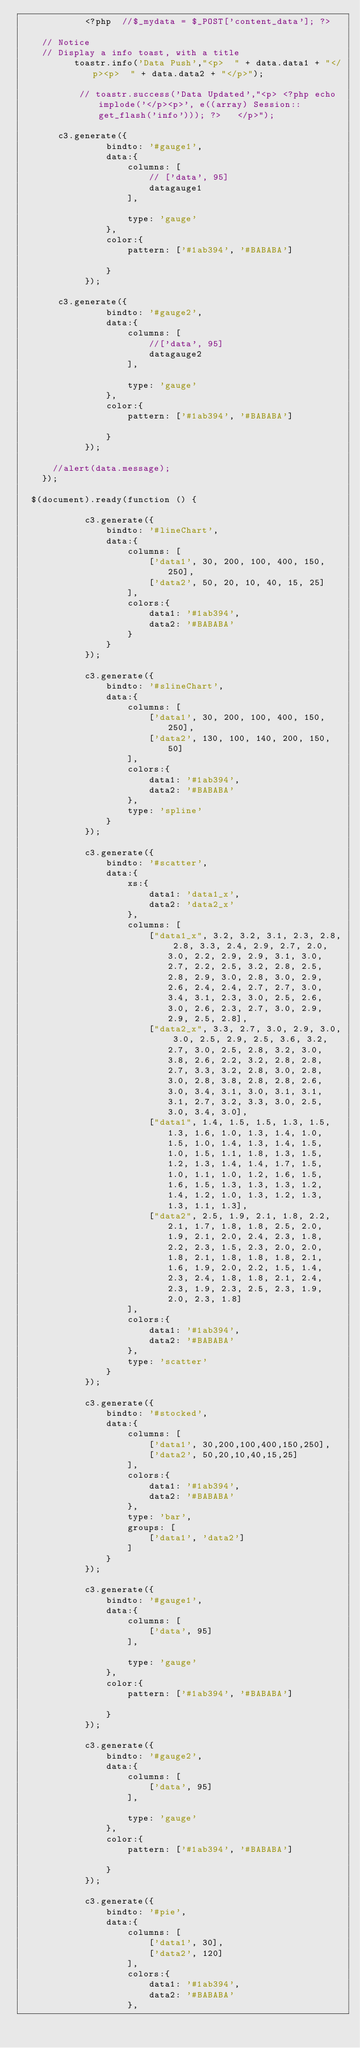Convert code to text. <code><loc_0><loc_0><loc_500><loc_500><_PHP_>           	<?php  //$_mydata = $_POST['content_data']; ?>

		// Notice 
		// Display a info toast, with a title
          toastr.info('Data Push',"<p>  " + data.data1 + "</p><p>  " + data.data2 + "</p>");

           // toastr.success('Data Updated',"<p> <?php echo implode('</p><p>', e((array) Session::get_flash('info'))); ?>  	</p>"); 

       c3.generate({
                bindto: '#gauge1',
                data:{
                    columns: [
                        // ['data', 95]
                        datagauge1
                    ],

                    type: 'gauge'
                },
                color:{
                    pattern: ['#1ab394', '#BABABA']

                }
            });

       c3.generate({
                bindto: '#gauge2',
                data:{
                    columns: [
                        //['data', 95]
                        datagauge2
                    ],

                    type: 'gauge'
                },
                color:{
                    pattern: ['#1ab394', '#BABABA']

                }
            });

      //alert(data.message);
    });

	$(document).ready(function () {

            c3.generate({
                bindto: '#lineChart',
                data:{
                    columns: [
                        ['data1', 30, 200, 100, 400, 150, 250],
                        ['data2', 50, 20, 10, 40, 15, 25]
                    ],
                    colors:{
                        data1: '#1ab394',
                        data2: '#BABABA'
                    }
                }
            });

            c3.generate({
                bindto: '#slineChart',
                data:{
                    columns: [
                        ['data1', 30, 200, 100, 400, 150, 250],
                        ['data2', 130, 100, 140, 200, 150, 50]
                    ],
                    colors:{
                        data1: '#1ab394',
                        data2: '#BABABA'
                    },
                    type: 'spline'
                }
            });

            c3.generate({
                bindto: '#scatter',
                data:{
                    xs:{
                        data1: 'data1_x',
                        data2: 'data2_x'
                    },
                    columns: [
                        ["data1_x", 3.2, 3.2, 3.1, 2.3, 2.8, 2.8, 3.3, 2.4, 2.9, 2.7, 2.0, 3.0, 2.2, 2.9, 2.9, 3.1, 3.0, 2.7, 2.2, 2.5, 3.2, 2.8, 2.5, 2.8, 2.9, 3.0, 2.8, 3.0, 2.9, 2.6, 2.4, 2.4, 2.7, 2.7, 3.0, 3.4, 3.1, 2.3, 3.0, 2.5, 2.6, 3.0, 2.6, 2.3, 2.7, 3.0, 2.9, 2.9, 2.5, 2.8],
                        ["data2_x", 3.3, 2.7, 3.0, 2.9, 3.0, 3.0, 2.5, 2.9, 2.5, 3.6, 3.2, 2.7, 3.0, 2.5, 2.8, 3.2, 3.0, 3.8, 2.6, 2.2, 3.2, 2.8, 2.8, 2.7, 3.3, 3.2, 2.8, 3.0, 2.8, 3.0, 2.8, 3.8, 2.8, 2.8, 2.6, 3.0, 3.4, 3.1, 3.0, 3.1, 3.1, 3.1, 2.7, 3.2, 3.3, 3.0, 2.5, 3.0, 3.4, 3.0],
                        ["data1", 1.4, 1.5, 1.5, 1.3, 1.5, 1.3, 1.6, 1.0, 1.3, 1.4, 1.0, 1.5, 1.0, 1.4, 1.3, 1.4, 1.5, 1.0, 1.5, 1.1, 1.8, 1.3, 1.5, 1.2, 1.3, 1.4, 1.4, 1.7, 1.5, 1.0, 1.1, 1.0, 1.2, 1.6, 1.5, 1.6, 1.5, 1.3, 1.3, 1.3, 1.2, 1.4, 1.2, 1.0, 1.3, 1.2, 1.3, 1.3, 1.1, 1.3],
                        ["data2", 2.5, 1.9, 2.1, 1.8, 2.2, 2.1, 1.7, 1.8, 1.8, 2.5, 2.0, 1.9, 2.1, 2.0, 2.4, 2.3, 1.8, 2.2, 2.3, 1.5, 2.3, 2.0, 2.0, 1.8, 2.1, 1.8, 1.8, 1.8, 2.1, 1.6, 1.9, 2.0, 2.2, 1.5, 1.4, 2.3, 2.4, 1.8, 1.8, 2.1, 2.4, 2.3, 1.9, 2.3, 2.5, 2.3, 1.9, 2.0, 2.3, 1.8]
                    ],
                    colors:{
                        data1: '#1ab394',
                        data2: '#BABABA'
                    },
                    type: 'scatter'
                }
            });

            c3.generate({
                bindto: '#stocked',
                data:{
                    columns: [
                        ['data1', 30,200,100,400,150,250],
                        ['data2', 50,20,10,40,15,25]
                    ],
                    colors:{
                        data1: '#1ab394',
                        data2: '#BABABA'
                    },
                    type: 'bar',
                    groups: [
                        ['data1', 'data2']
                    ]
                }
            });

            c3.generate({
                bindto: '#gauge1',
                data:{
                    columns: [
                        ['data', 95]
                    ],

                    type: 'gauge'
                },
                color:{
                    pattern: ['#1ab394', '#BABABA']

                }
            });

            c3.generate({
                bindto: '#gauge2',
                data:{
                    columns: [
                        ['data', 95]
                    ],

                    type: 'gauge'
                },
                color:{
                    pattern: ['#1ab394', '#BABABA']

                }
            });

            c3.generate({
                bindto: '#pie',
                data:{
                    columns: [
                        ['data1', 30],
                        ['data2', 120]
                    ],
                    colors:{
                        data1: '#1ab394',
                        data2: '#BABABA'
                    },</code> 